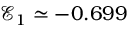<formula> <loc_0><loc_0><loc_500><loc_500>\mathcal { E } _ { 1 } \simeq - 0 . 6 9 9</formula> 